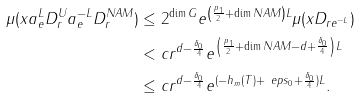Convert formula to latex. <formula><loc_0><loc_0><loc_500><loc_500>\mu ( x a _ { e } ^ { L } D _ { r } ^ { U } a _ { e } ^ { - L } D _ { r } ^ { N A M } ) & \leq 2 ^ { \dim G } e ^ { \left ( \frac { p _ { 1 } } { 2 } + \dim N A M \right ) L } \mu ( x D _ { r e ^ { - L } } ) \\ & < c r ^ { d - \frac { \delta _ { 0 } } { 4 } } e ^ { \left ( \frac { p _ { 1 } } { 2 } + \dim N A M - d + \frac { \delta _ { 0 } } { 4 } \right ) L } \\ & \leq c r ^ { d - \frac { \delta _ { 0 } } { 4 } } e ^ { ( - h _ { m } ( T ) + \ e p s _ { 0 } + \frac { \delta _ { 0 } } { 4 } ) L } .</formula> 